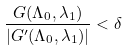<formula> <loc_0><loc_0><loc_500><loc_500>\frac { G ( \Lambda _ { 0 } , \lambda _ { 1 } ) } { | G ^ { \prime } ( \Lambda _ { 0 } , \lambda _ { 1 } ) | } < \delta</formula> 